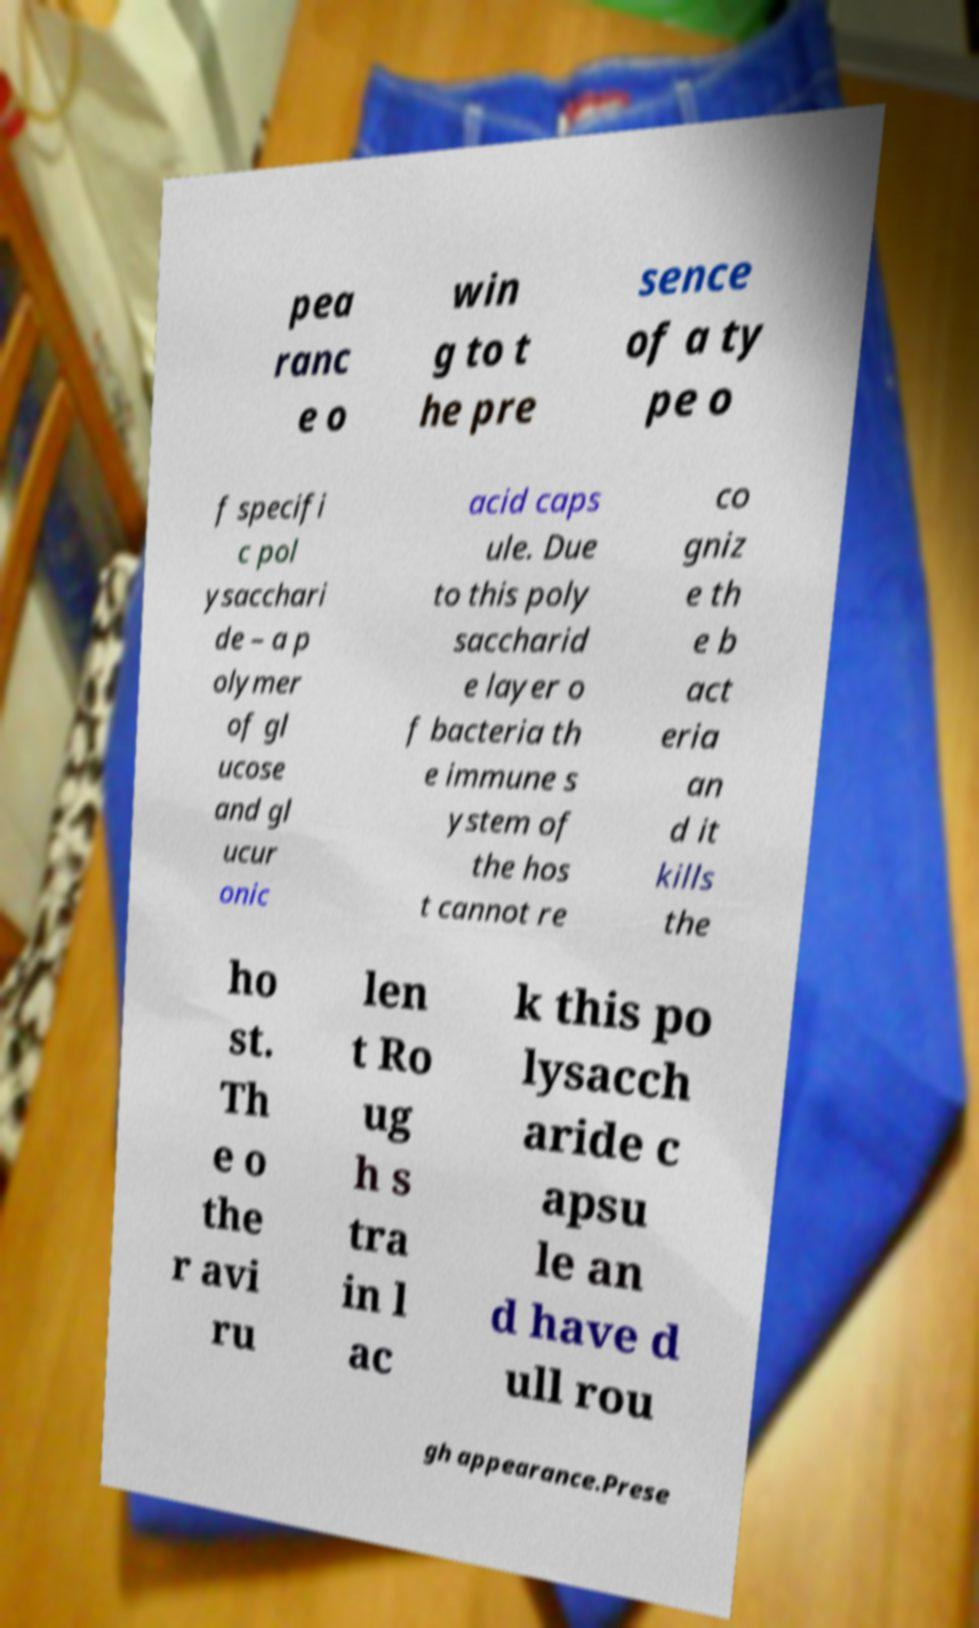Can you accurately transcribe the text from the provided image for me? pea ranc e o win g to t he pre sence of a ty pe o f specifi c pol ysacchari de – a p olymer of gl ucose and gl ucur onic acid caps ule. Due to this poly saccharid e layer o f bacteria th e immune s ystem of the hos t cannot re co gniz e th e b act eria an d it kills the ho st. Th e o the r avi ru len t Ro ug h s tra in l ac k this po lysacch aride c apsu le an d have d ull rou gh appearance.Prese 